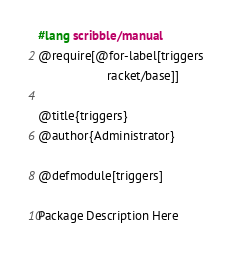Convert code to text. <code><loc_0><loc_0><loc_500><loc_500><_Racket_>#lang scribble/manual
@require[@for-label[triggers
                    racket/base]]

@title{triggers}
@author{Administrator}

@defmodule[triggers]

Package Description Here
</code> 